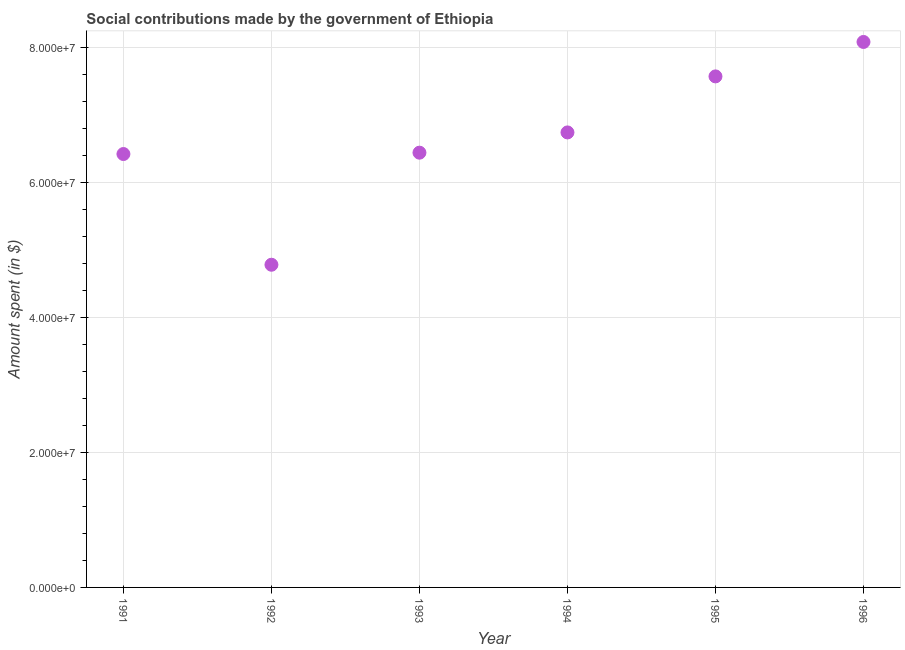What is the amount spent in making social contributions in 1996?
Offer a terse response. 8.08e+07. Across all years, what is the maximum amount spent in making social contributions?
Give a very brief answer. 8.08e+07. Across all years, what is the minimum amount spent in making social contributions?
Your response must be concise. 4.78e+07. In which year was the amount spent in making social contributions maximum?
Offer a terse response. 1996. What is the sum of the amount spent in making social contributions?
Keep it short and to the point. 4.00e+08. What is the difference between the amount spent in making social contributions in 1991 and 1996?
Give a very brief answer. -1.66e+07. What is the average amount spent in making social contributions per year?
Offer a very short reply. 6.67e+07. What is the median amount spent in making social contributions?
Make the answer very short. 6.59e+07. In how many years, is the amount spent in making social contributions greater than 32000000 $?
Offer a very short reply. 6. Do a majority of the years between 1991 and 1996 (inclusive) have amount spent in making social contributions greater than 8000000 $?
Make the answer very short. Yes. What is the ratio of the amount spent in making social contributions in 1995 to that in 1996?
Make the answer very short. 0.94. Is the amount spent in making social contributions in 1993 less than that in 1996?
Provide a succinct answer. Yes. Is the difference between the amount spent in making social contributions in 1995 and 1996 greater than the difference between any two years?
Keep it short and to the point. No. What is the difference between the highest and the second highest amount spent in making social contributions?
Give a very brief answer. 5.10e+06. What is the difference between the highest and the lowest amount spent in making social contributions?
Your response must be concise. 3.30e+07. How many dotlines are there?
Your answer should be compact. 1. How many years are there in the graph?
Offer a very short reply. 6. Does the graph contain any zero values?
Offer a very short reply. No. Does the graph contain grids?
Your response must be concise. Yes. What is the title of the graph?
Provide a succinct answer. Social contributions made by the government of Ethiopia. What is the label or title of the Y-axis?
Offer a terse response. Amount spent (in $). What is the Amount spent (in $) in 1991?
Make the answer very short. 6.42e+07. What is the Amount spent (in $) in 1992?
Your answer should be compact. 4.78e+07. What is the Amount spent (in $) in 1993?
Offer a very short reply. 6.44e+07. What is the Amount spent (in $) in 1994?
Offer a terse response. 6.74e+07. What is the Amount spent (in $) in 1995?
Your answer should be very brief. 7.57e+07. What is the Amount spent (in $) in 1996?
Provide a short and direct response. 8.08e+07. What is the difference between the Amount spent (in $) in 1991 and 1992?
Ensure brevity in your answer.  1.64e+07. What is the difference between the Amount spent (in $) in 1991 and 1993?
Provide a short and direct response. -2.00e+05. What is the difference between the Amount spent (in $) in 1991 and 1994?
Provide a succinct answer. -3.20e+06. What is the difference between the Amount spent (in $) in 1991 and 1995?
Keep it short and to the point. -1.15e+07. What is the difference between the Amount spent (in $) in 1991 and 1996?
Provide a succinct answer. -1.66e+07. What is the difference between the Amount spent (in $) in 1992 and 1993?
Offer a very short reply. -1.66e+07. What is the difference between the Amount spent (in $) in 1992 and 1994?
Provide a succinct answer. -1.96e+07. What is the difference between the Amount spent (in $) in 1992 and 1995?
Keep it short and to the point. -2.79e+07. What is the difference between the Amount spent (in $) in 1992 and 1996?
Provide a succinct answer. -3.30e+07. What is the difference between the Amount spent (in $) in 1993 and 1994?
Give a very brief answer. -3.00e+06. What is the difference between the Amount spent (in $) in 1993 and 1995?
Offer a very short reply. -1.13e+07. What is the difference between the Amount spent (in $) in 1993 and 1996?
Offer a terse response. -1.64e+07. What is the difference between the Amount spent (in $) in 1994 and 1995?
Make the answer very short. -8.30e+06. What is the difference between the Amount spent (in $) in 1994 and 1996?
Your answer should be compact. -1.34e+07. What is the difference between the Amount spent (in $) in 1995 and 1996?
Your response must be concise. -5.10e+06. What is the ratio of the Amount spent (in $) in 1991 to that in 1992?
Give a very brief answer. 1.34. What is the ratio of the Amount spent (in $) in 1991 to that in 1994?
Provide a short and direct response. 0.95. What is the ratio of the Amount spent (in $) in 1991 to that in 1995?
Offer a terse response. 0.85. What is the ratio of the Amount spent (in $) in 1991 to that in 1996?
Your answer should be compact. 0.8. What is the ratio of the Amount spent (in $) in 1992 to that in 1993?
Offer a very short reply. 0.74. What is the ratio of the Amount spent (in $) in 1992 to that in 1994?
Provide a short and direct response. 0.71. What is the ratio of the Amount spent (in $) in 1992 to that in 1995?
Offer a very short reply. 0.63. What is the ratio of the Amount spent (in $) in 1992 to that in 1996?
Keep it short and to the point. 0.59. What is the ratio of the Amount spent (in $) in 1993 to that in 1994?
Offer a very short reply. 0.95. What is the ratio of the Amount spent (in $) in 1993 to that in 1995?
Ensure brevity in your answer.  0.85. What is the ratio of the Amount spent (in $) in 1993 to that in 1996?
Your answer should be very brief. 0.8. What is the ratio of the Amount spent (in $) in 1994 to that in 1995?
Your answer should be compact. 0.89. What is the ratio of the Amount spent (in $) in 1994 to that in 1996?
Give a very brief answer. 0.83. What is the ratio of the Amount spent (in $) in 1995 to that in 1996?
Your response must be concise. 0.94. 